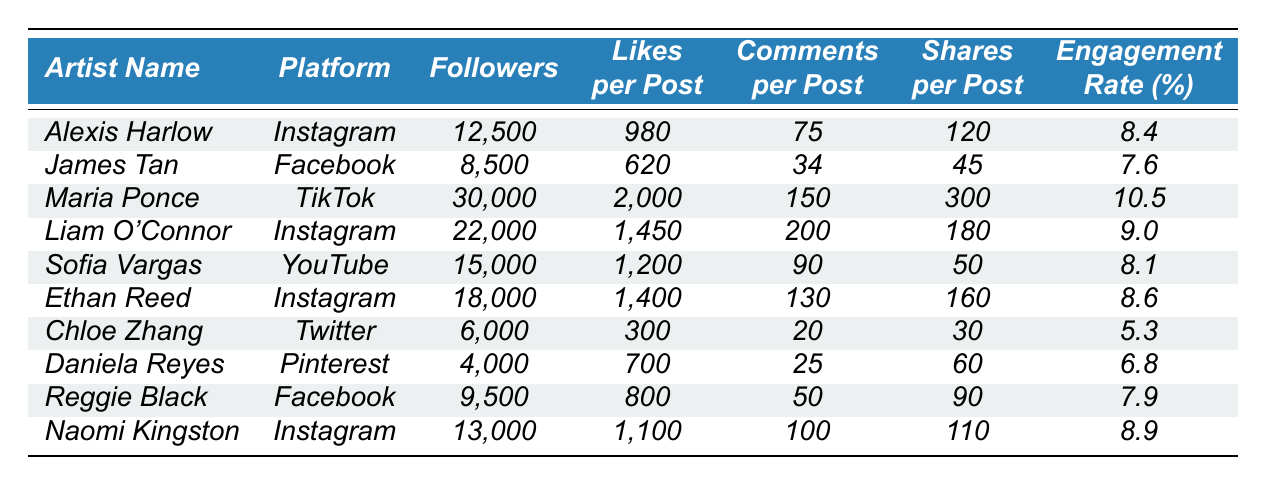What is the engagement rate of Maria Ponce? The table lists Maria Ponce's engagement rate directly as 10.5%.
Answer: 10.5% Which artist has the most followers? Looking at the table, Maria Ponce has the most followers at 30,000.
Answer: Maria Ponce What is the average likes per post for all artists featured on Instagram? The artists on Instagram are Alexis Harlow (980), Liam O'Connor (1450), Ethan Reed (1400), and Naomi Kingston (1100). Adding these gives 980 + 1450 + 1400 + 1100 = 3930, and dividing by 4 artists results in an average of 982.5.
Answer: 982.5 Is Chloe Zhang's engagement rate higher than that of James Tan? Chloe Zhang has an engagement rate of 5.3%, while James Tan has an engagement rate of 7.6%. Since 5.3% is not higher than 7.6%, the answer is no.
Answer: No Which platform has the artist with the highest engagement rate? Maria Ponce on TikTok has the highest engagement rate of 10.5% among the listed artists, while no other platform matches this.
Answer: TikTok If we compare the shares per post for Ethan Reed and Reggie Black, who has more? Ethan Reed has 160 shares per post, while Reggie Black has 90 shares per post. Since 160 is greater than 90, Ethan Reed has more shares.
Answer: Ethan Reed What is the total number of followers for all artists on Facebook? The artists on Facebook are James Tan with 8,500 followers and Reggie Black with 9,500 followers. Adding these gives 8,500 + 9,500 = 18,000 followers total on Facebook.
Answer: 18,000 Who has the fewest comments per post and what is that number? Chloe Zhang has the fewest comments per post with a total of 20 comments.
Answer: 20 What is the difference in engagement rates between the highest and lowest engagement rates? The highest engagement rate is that of Maria Ponce at 10.5% and the lowest is Chloe Zhang at 5.3%. The difference is 10.5% - 5.3% = 5.2%.
Answer: 5.2% Are there more artists with an engagement rate above 9% or below 7%? The artists with engagement rates above 9% are Maria Ponce (10.5%), Liam O'Connor (9.0%), and Naomi Kingston (8.9%) totaling 3 artists, while those below 7% are Daniela Reyes (6.8%) and Chloe Zhang (5.3%) totaling 2 artists. Therefore, there are more artists above 9%.
Answer: Above 9% 